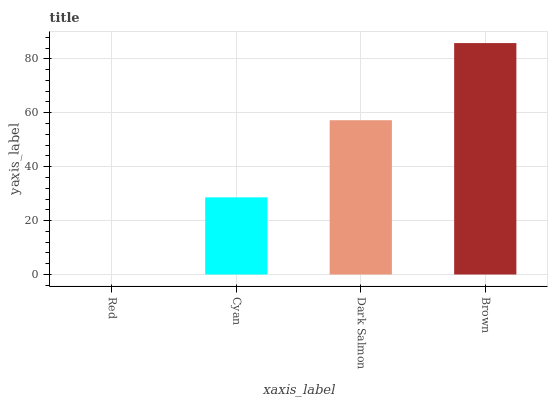Is Cyan the minimum?
Answer yes or no. No. Is Cyan the maximum?
Answer yes or no. No. Is Cyan greater than Red?
Answer yes or no. Yes. Is Red less than Cyan?
Answer yes or no. Yes. Is Red greater than Cyan?
Answer yes or no. No. Is Cyan less than Red?
Answer yes or no. No. Is Dark Salmon the high median?
Answer yes or no. Yes. Is Cyan the low median?
Answer yes or no. Yes. Is Brown the high median?
Answer yes or no. No. Is Dark Salmon the low median?
Answer yes or no. No. 